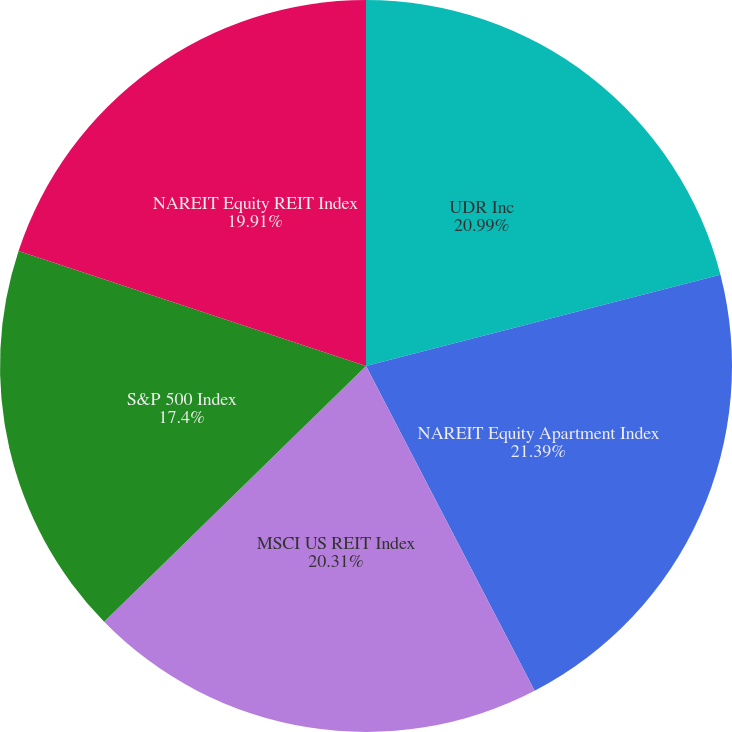<chart> <loc_0><loc_0><loc_500><loc_500><pie_chart><fcel>UDR Inc<fcel>NAREIT Equity Apartment Index<fcel>MSCI US REIT Index<fcel>S&P 500 Index<fcel>NAREIT Equity REIT Index<nl><fcel>20.99%<fcel>21.39%<fcel>20.31%<fcel>17.4%<fcel>19.91%<nl></chart> 